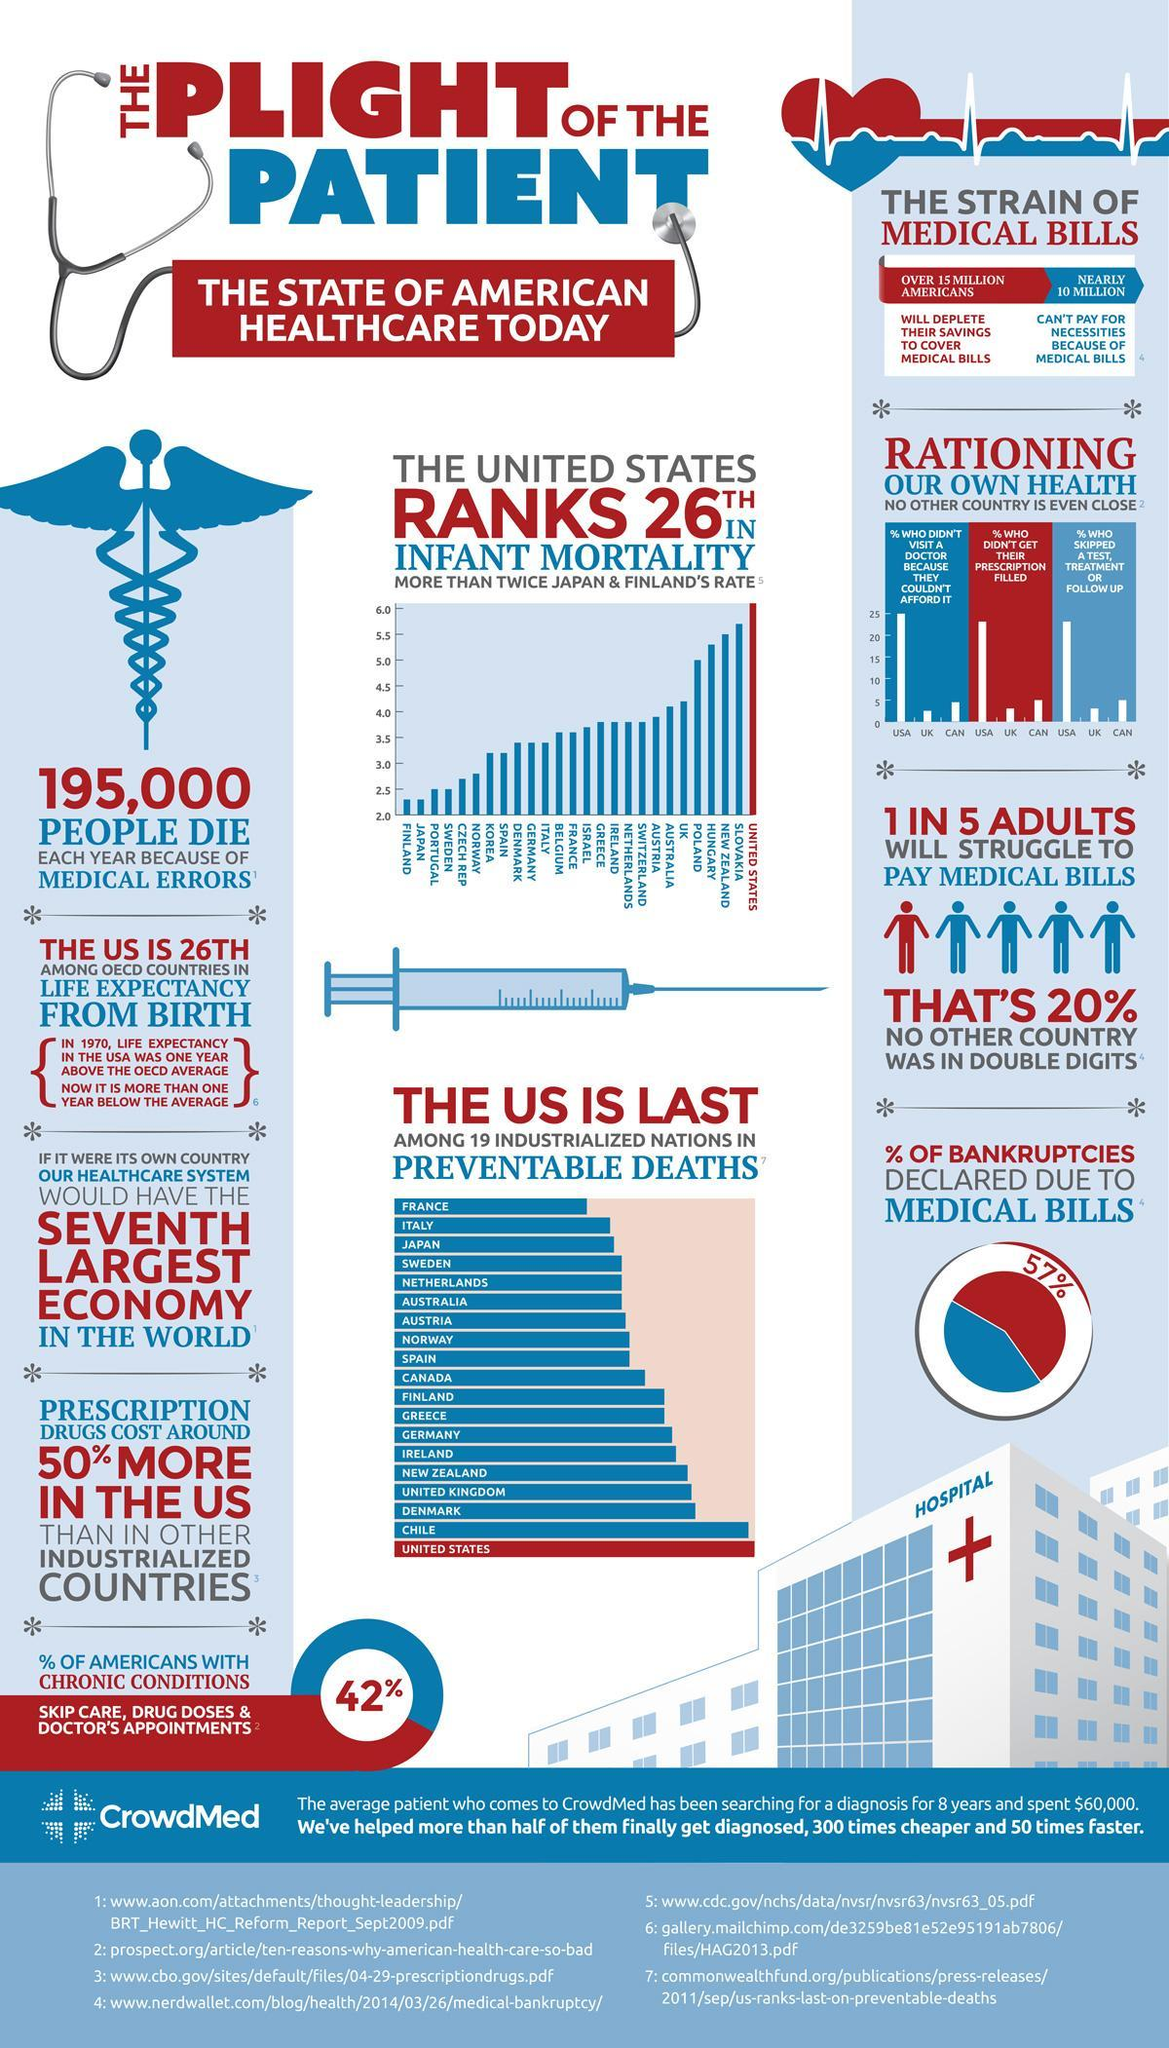How many people in the U.S. died each year because of medical errors?
Answer the question with a short phrase. 195,000 What percentage of bankruptcies declared in the U.S. is due to medical bills? 57% What percentage of Americans have chronic health conditions? 42% How many Americans can't pay for their necessities because of medical bills? NEARLY 10 MILLION How many Americans will deplete their savings to cover medical bills? OVER 15 MILLION Which is the top industrialized nation in preventable deaths? FRANCE 